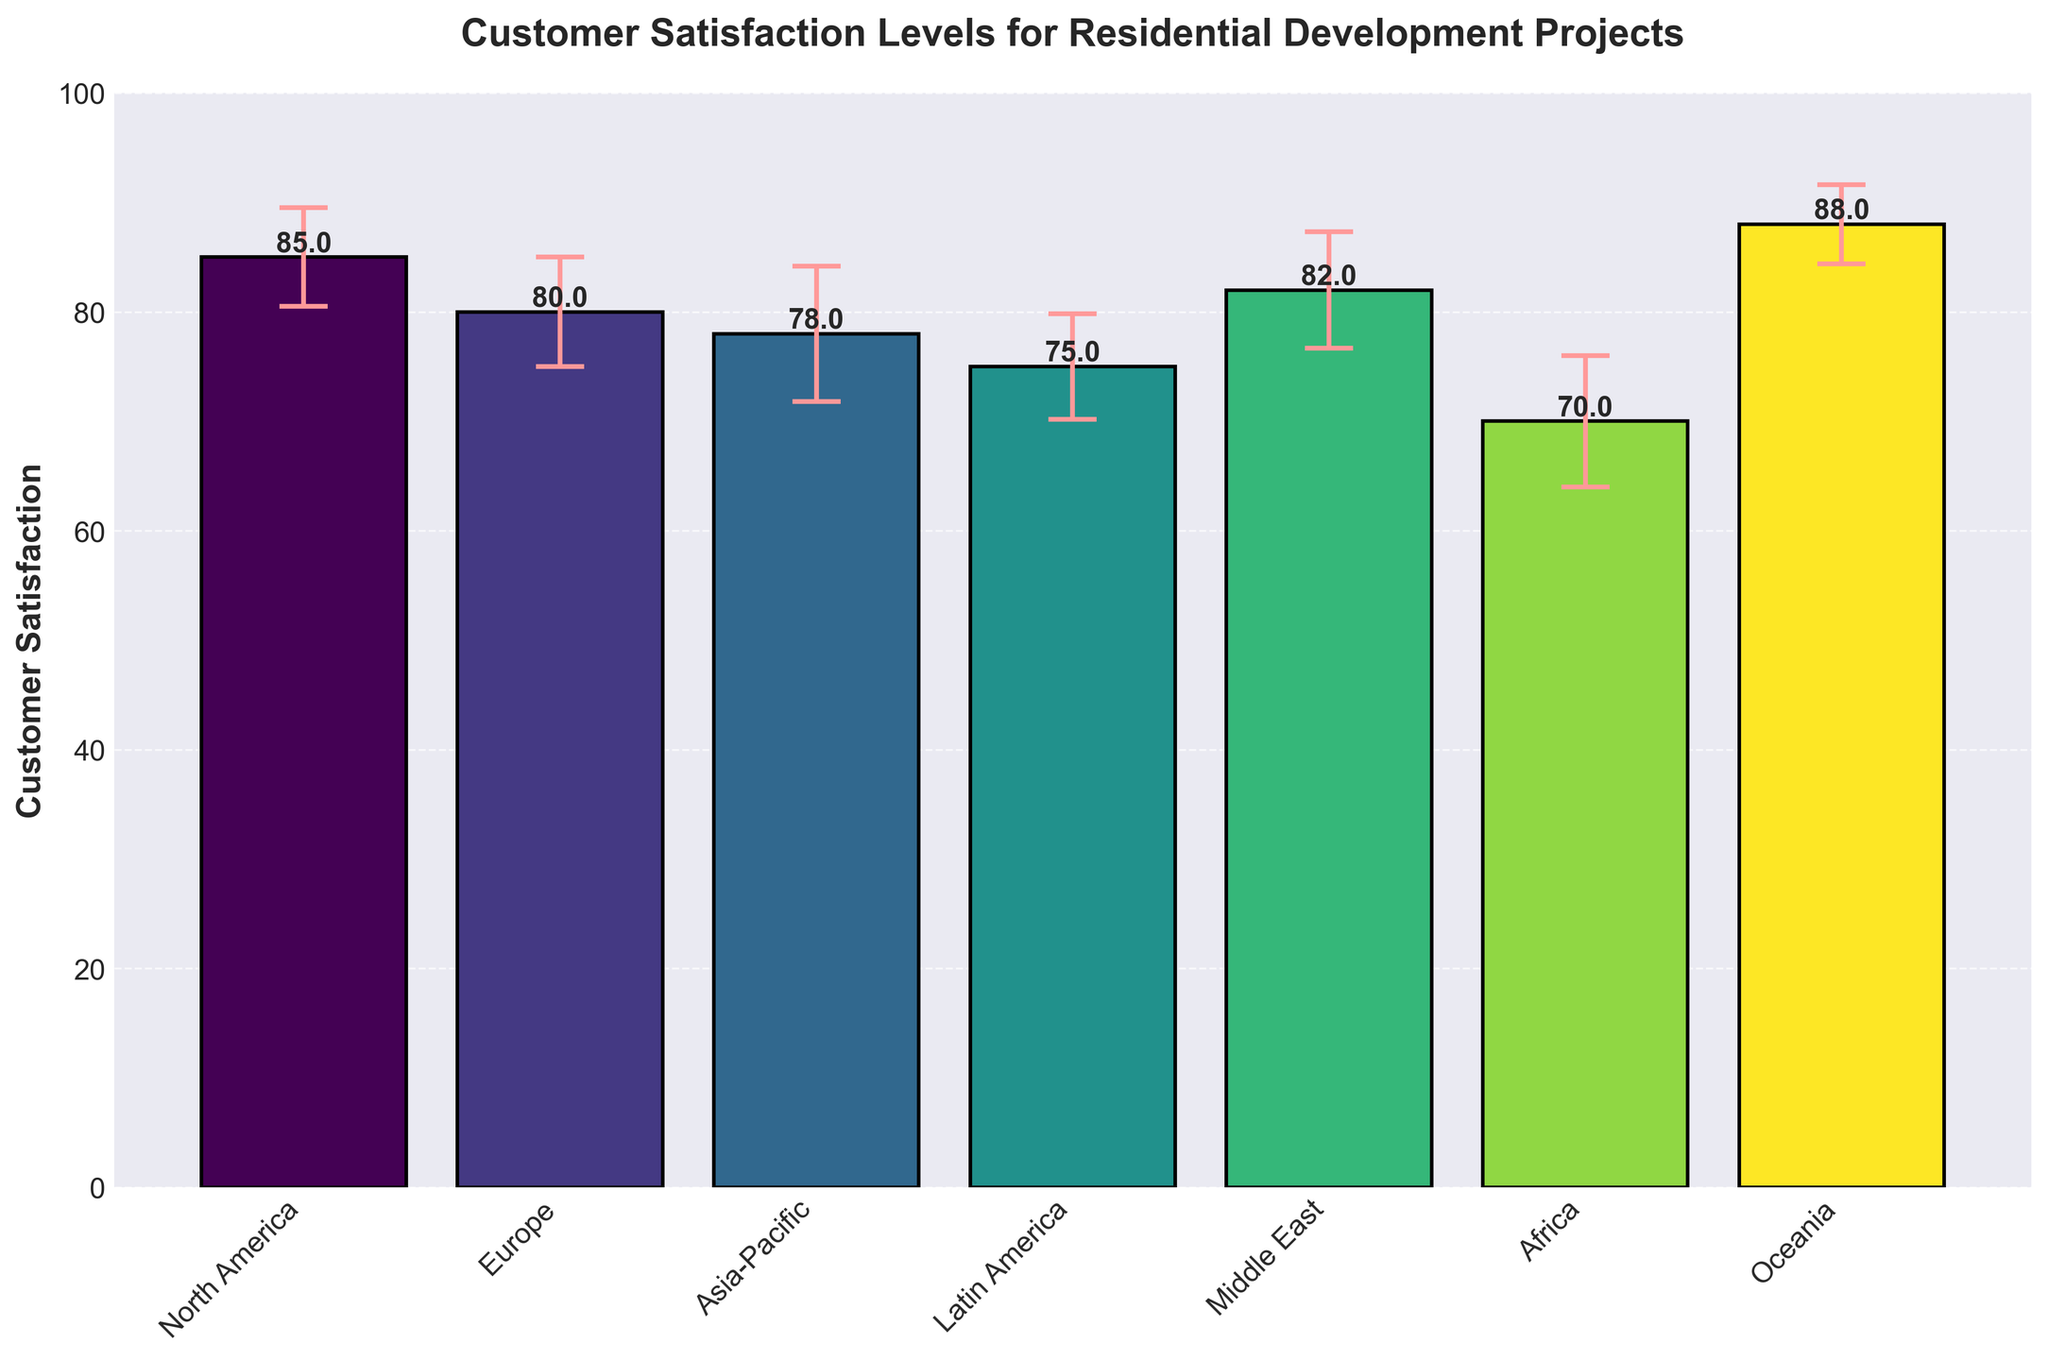what is the title of the figure? The title is typically found at the top of the figure. In this case, it reads “Customer Satisfaction Levels for Residential Development Projects.”
Answer: Customer Satisfaction Levels for Residential Development Projects what does the y-axis represent? The label on the y-axis indicates what the data points are measuring. Here, it’s labeled "Customer Satisfaction."
Answer: Customer Satisfaction which region has the highest customer satisfaction level? By comparing the heights of the bars, we can identify that Oceania has the highest bar, indicating the highest customer satisfaction level of 88.
Answer: Oceania What is the Average Customer Satisfaction Across All Regions? To find the average, sum the customer satisfaction levels for all regions and then divide by the number of regions: (85 + 80 + 78 + 75 + 82 + 70 + 88) ÷ 7 = 79.71
Answer: 79.71 Which region has the largest standard deviation in customer satisfaction? By observing the error bars in the chart, Asia-Pacific has the largest error bar, indicating a standard deviation of 6.2.
Answer: Asia-Pacific How much higher is the Customer Satisfaction in North America compared to Africa? North America has 85 and Africa has 70. The difference is 85 - 70 = 15.
Answer: 15 What is the total range of Customer Satisfaction levels in the figure? The range is the difference between the highest and lowest values. Oceania is 88, and Africa is 70. The range is 88 - 70 = 18.
Answer: 18 Which regions have a Customer Satisfaction Level greater than 80? By looking at the height of the bars, North America (85), Europe (80), Middle East (82), and Oceania (88) have levels greater than 80.
Answer: North America, Middle East, Oceania What is the median Customer Satisfaction Level across all regions? Order the satisfaction levels: 70, 75, 78, 80, 82, 85, 88. The median is the middle value, which is 80.
Answer: 80 How does the Standard Deviation for Europe compare to that of Africa? Europe has a standard deviation of 5.0, while Africa has a standard deviation of 6.0. Africa’s standard deviation is larger by 1.0.
Answer: Africa's is larger by 1.0 